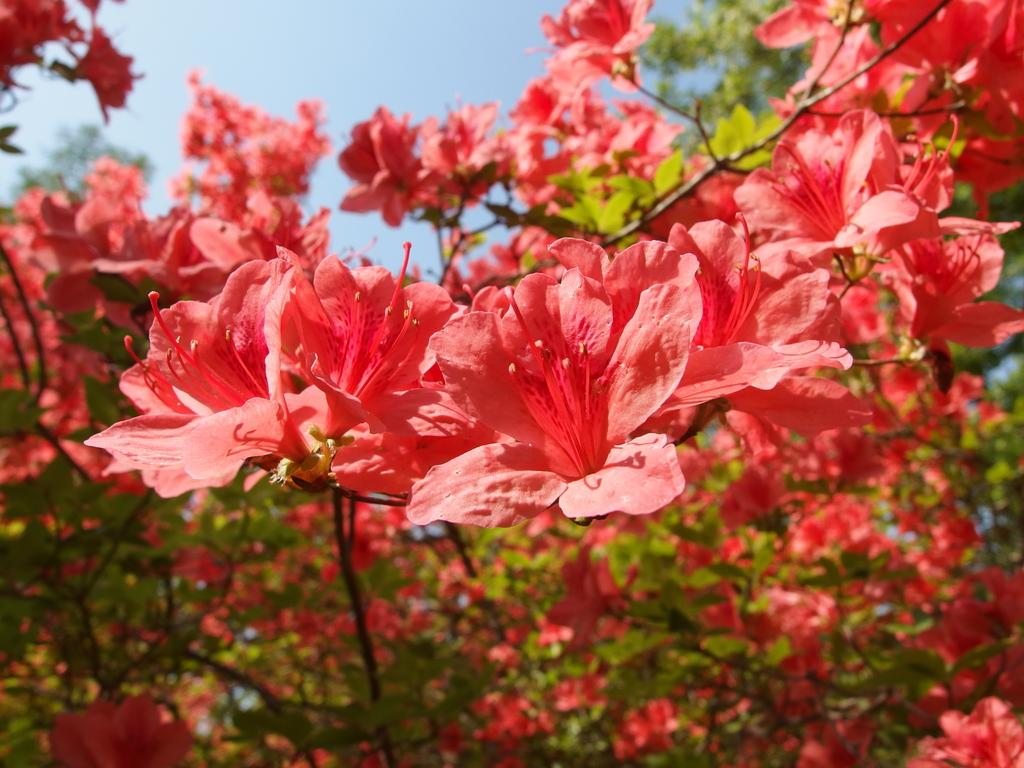What type of vegetation can be seen in the image? There are trees and flowers in the image. What can be seen in the background of the image? The sky is visible in the background of the image. What type of teaching method is being used by the nerve in the image? There is no teaching or nerve present in the image; it features trees, flowers, and the sky. 